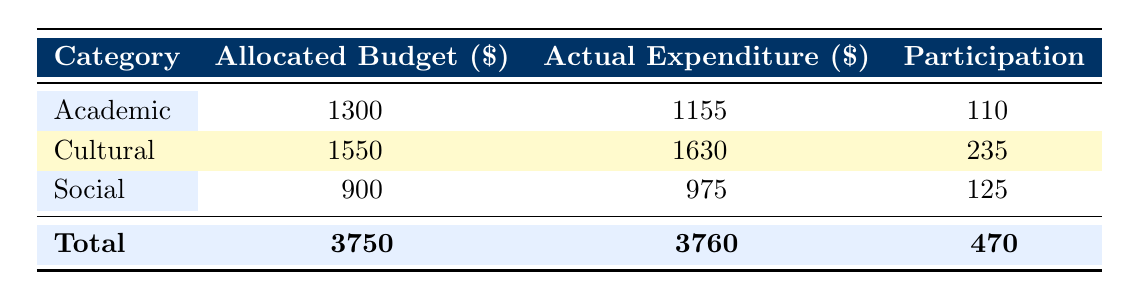What is the allocated budget for cultural initiatives? The table indicates that the allocated budget for cultural initiatives is listed in the "Allocated Budget" column for the "Cultural" category. The total for this category is 1550.
Answer: 1550 What is the actual expenditure for social initiatives? To find the total actual expenditure for social initiatives, we refer to the "Actual Expenditure" column for the "Social" category, which sums up to 975.
Answer: 975 Is the total actual expenditure greater than or less than the total allocated budget? By comparing the total actual expenditure (3760) to the total allocated budget (3750), we can see that the actual expenditure is greater. Since 3760 > 3750, the answer is yes.
Answer: Yes What is the average participation for academic initiatives? First, we sum the participation numbers for the academic initiatives, which are 35, 25, and 30, totaling 90. Then, we divide this by the number of academic initiatives, which is 3 (90/3 = 30).
Answer: 30 Which category had the highest amount of total expenditure? Checking the "Actual Expenditure" totals for each category, social initiatives total 975, academic total 1155, and cultural total 1630. Comparing these, it's evident that cultural initiatives have the highest total expenditure.
Answer: Cultural What is the difference between allocated budget and actual expenditure for academic initiatives? To find the difference, we take the total allocated budget for academic initiatives (1300) and subtract the total actual expenditure (1155), resulting in a difference of 145 (1300 - 1155 = 145).
Answer: 145 Did any initiative exceed its allocated budget? By examining the "Actual Expenditure" for each initiative against its "Allocated Budget", we see that the "Jane Austen Tea Party" and the "Victorian Era Costume Ball" both exceeded their budgets (325 > 300 and 650 > 600). Thus, the answer is yes.
Answer: Yes What is the total participation across all initiatives? To determine the total participation, we add the participation numbers from each initiative (35 + 50 + 25 + 30 + 40 + 75 + 60 + 20 + 90 + 45). This results in a total of 470.
Answer: 470 Which academic initiative had the lowest actual expenditure? Looking at the "Actual Expenditure" for academic initiatives, we see that the "Bronte Sisters Book Club" had an expenditure of 125, which is lower than the others (450, 380, 200).
Answer: Bronte Sisters Book Club 